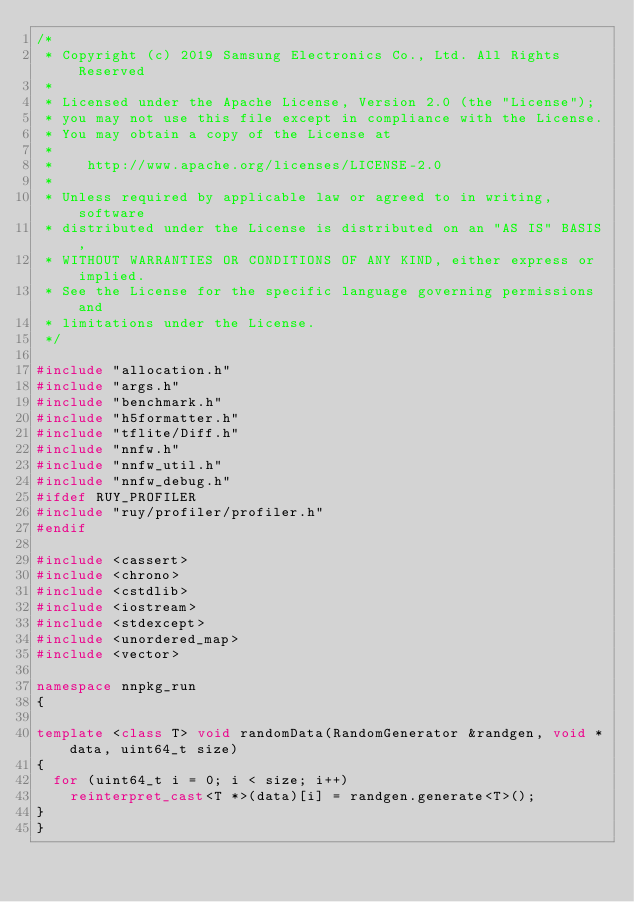Convert code to text. <code><loc_0><loc_0><loc_500><loc_500><_C++_>/*
 * Copyright (c) 2019 Samsung Electronics Co., Ltd. All Rights Reserved
 *
 * Licensed under the Apache License, Version 2.0 (the "License");
 * you may not use this file except in compliance with the License.
 * You may obtain a copy of the License at
 *
 *    http://www.apache.org/licenses/LICENSE-2.0
 *
 * Unless required by applicable law or agreed to in writing, software
 * distributed under the License is distributed on an "AS IS" BASIS,
 * WITHOUT WARRANTIES OR CONDITIONS OF ANY KIND, either express or implied.
 * See the License for the specific language governing permissions and
 * limitations under the License.
 */

#include "allocation.h"
#include "args.h"
#include "benchmark.h"
#include "h5formatter.h"
#include "tflite/Diff.h"
#include "nnfw.h"
#include "nnfw_util.h"
#include "nnfw_debug.h"
#ifdef RUY_PROFILER
#include "ruy/profiler/profiler.h"
#endif

#include <cassert>
#include <chrono>
#include <cstdlib>
#include <iostream>
#include <stdexcept>
#include <unordered_map>
#include <vector>

namespace nnpkg_run
{

template <class T> void randomData(RandomGenerator &randgen, void *data, uint64_t size)
{
  for (uint64_t i = 0; i < size; i++)
    reinterpret_cast<T *>(data)[i] = randgen.generate<T>();
}
}
</code> 